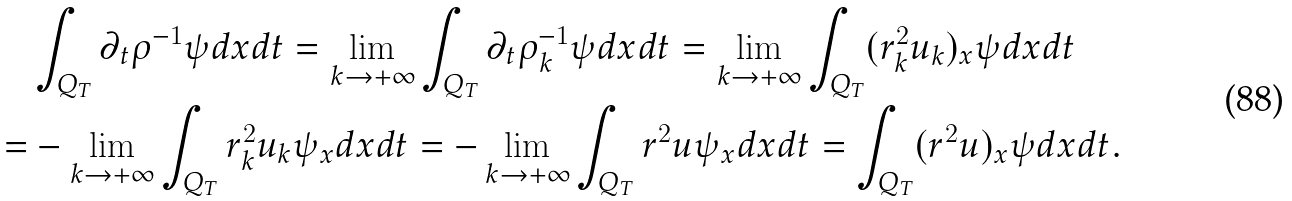Convert formula to latex. <formula><loc_0><loc_0><loc_500><loc_500>& \int _ { Q _ { T } } \partial _ { t } \rho ^ { - 1 } \psi d x d t = \lim _ { k \rightarrow + \infty } \int _ { Q _ { T } } \partial _ { t } \rho ^ { - 1 } _ { k } \psi d x d t = \lim _ { k \rightarrow + \infty } \int _ { Q _ { T } } ( r ^ { 2 } _ { k } u _ { k } ) _ { x } \psi d x d t \\ = & - \lim _ { k \rightarrow + \infty } \int _ { Q _ { T } } r _ { k } ^ { 2 } u _ { k } \psi _ { x } d x d t = - \lim _ { k \rightarrow + \infty } \int _ { Q _ { T } } r ^ { 2 } u \psi _ { x } d x d t = \int _ { Q _ { T } } ( r ^ { 2 } u ) _ { x } \psi d x d t .</formula> 